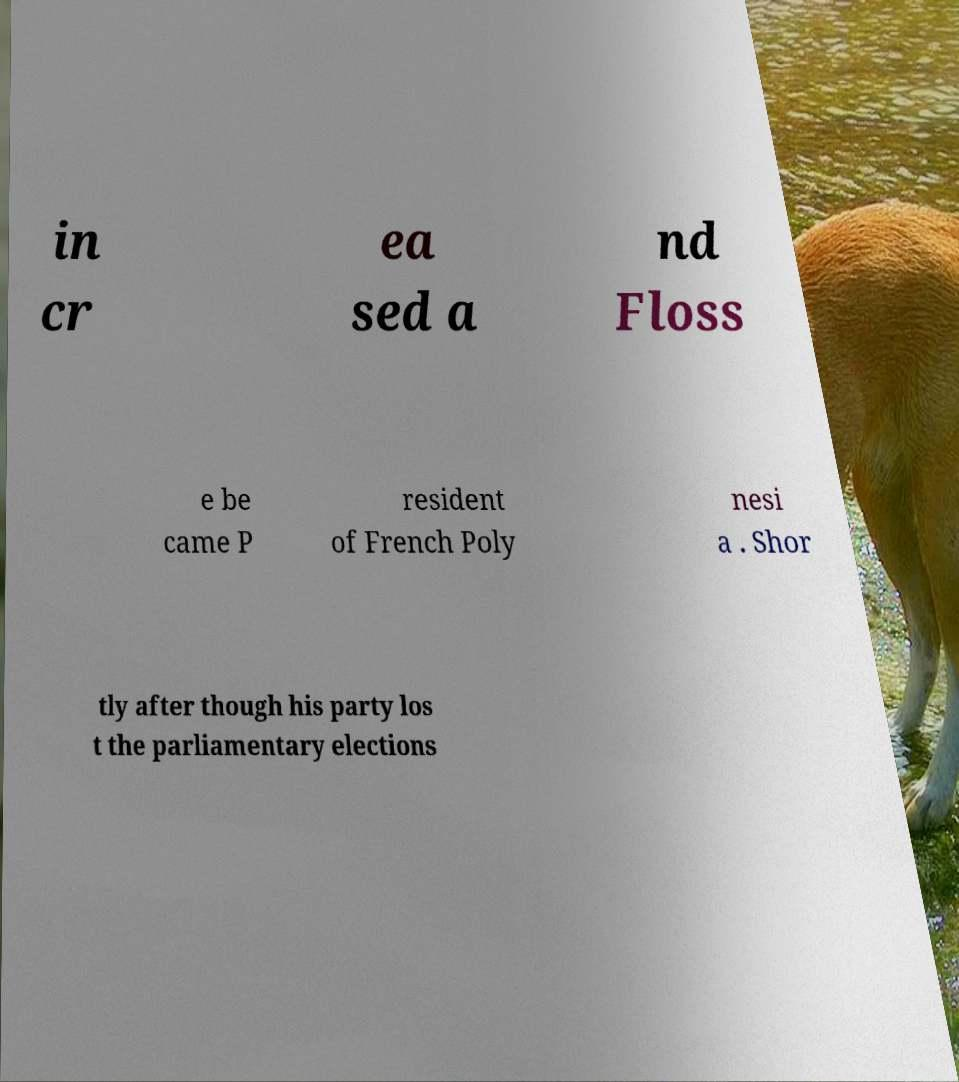What messages or text are displayed in this image? I need them in a readable, typed format. in cr ea sed a nd Floss e be came P resident of French Poly nesi a . Shor tly after though his party los t the parliamentary elections 